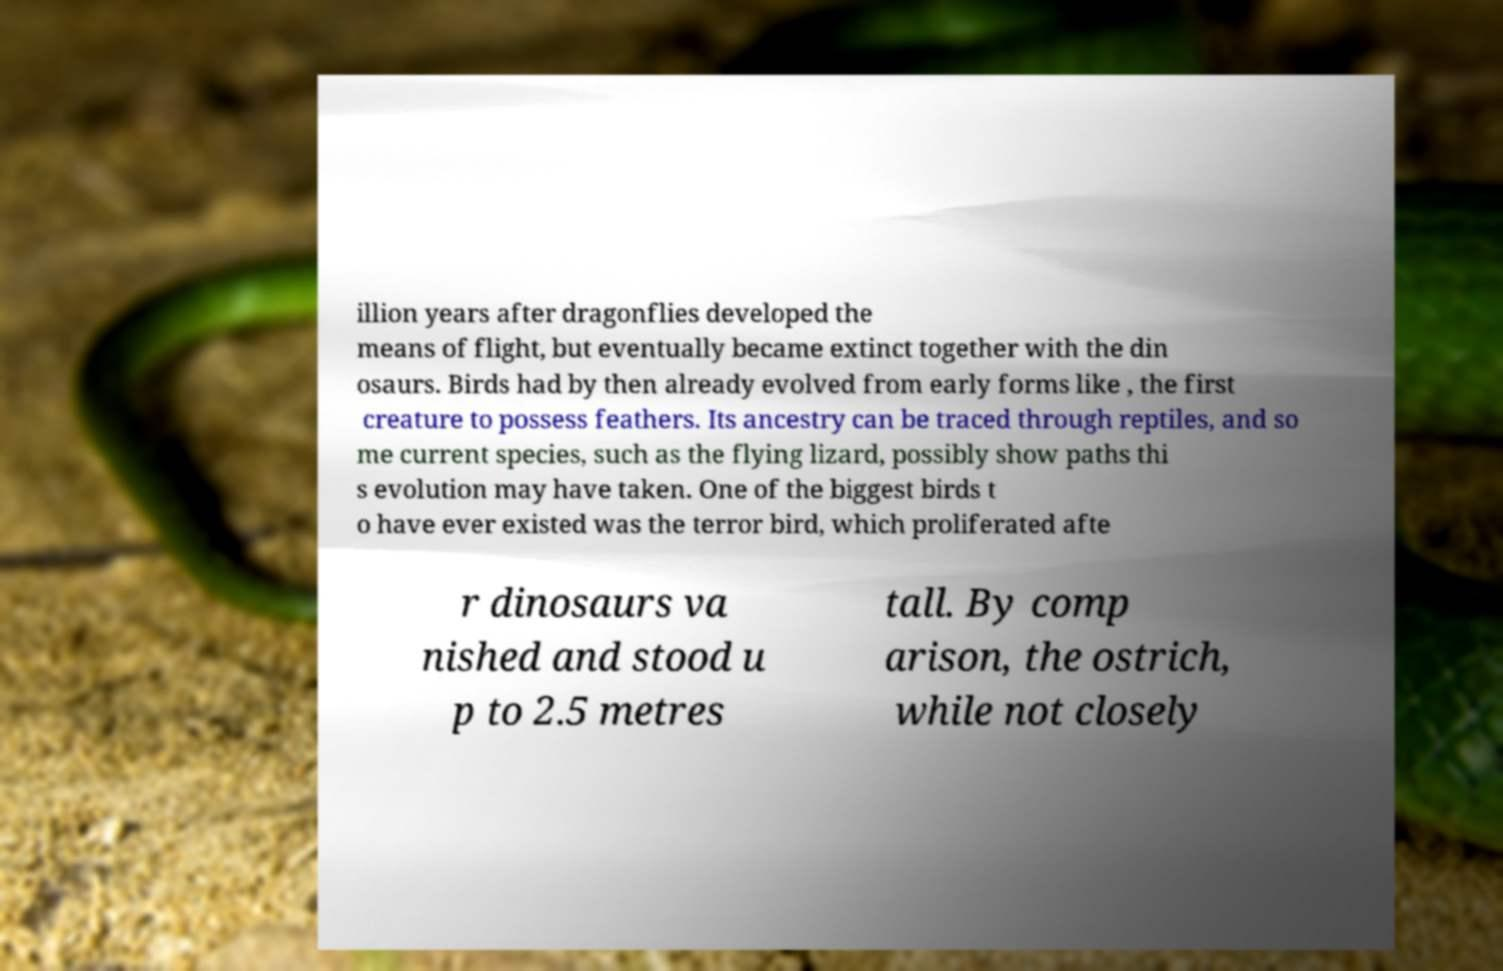For documentation purposes, I need the text within this image transcribed. Could you provide that? illion years after dragonflies developed the means of flight, but eventually became extinct together with the din osaurs. Birds had by then already evolved from early forms like , the first creature to possess feathers. Its ancestry can be traced through reptiles, and so me current species, such as the flying lizard, possibly show paths thi s evolution may have taken. One of the biggest birds t o have ever existed was the terror bird, which proliferated afte r dinosaurs va nished and stood u p to 2.5 metres tall. By comp arison, the ostrich, while not closely 